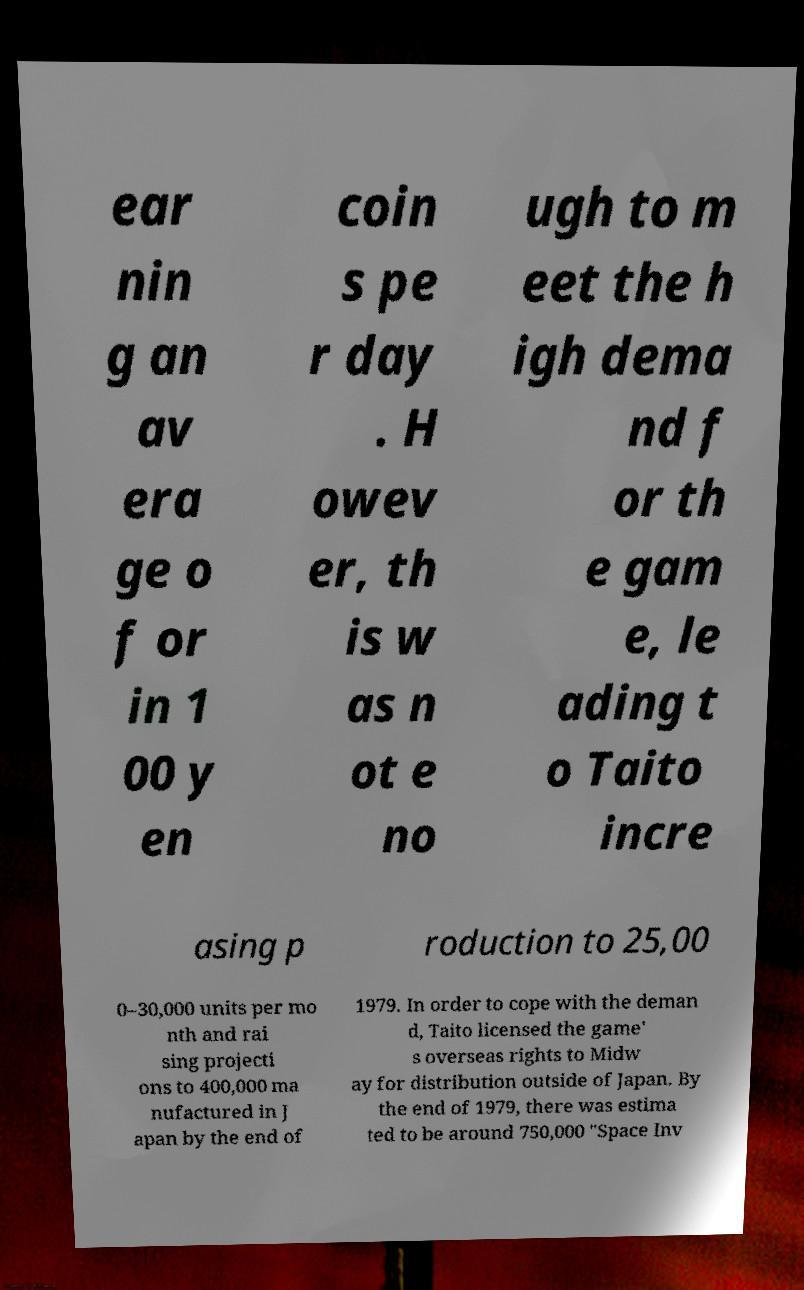For documentation purposes, I need the text within this image transcribed. Could you provide that? ear nin g an av era ge o f or in 1 00 y en coin s pe r day . H owev er, th is w as n ot e no ugh to m eet the h igh dema nd f or th e gam e, le ading t o Taito incre asing p roduction to 25,00 0–30,000 units per mo nth and rai sing projecti ons to 400,000 ma nufactured in J apan by the end of 1979. In order to cope with the deman d, Taito licensed the game' s overseas rights to Midw ay for distribution outside of Japan. By the end of 1979, there was estima ted to be around 750,000 "Space Inv 